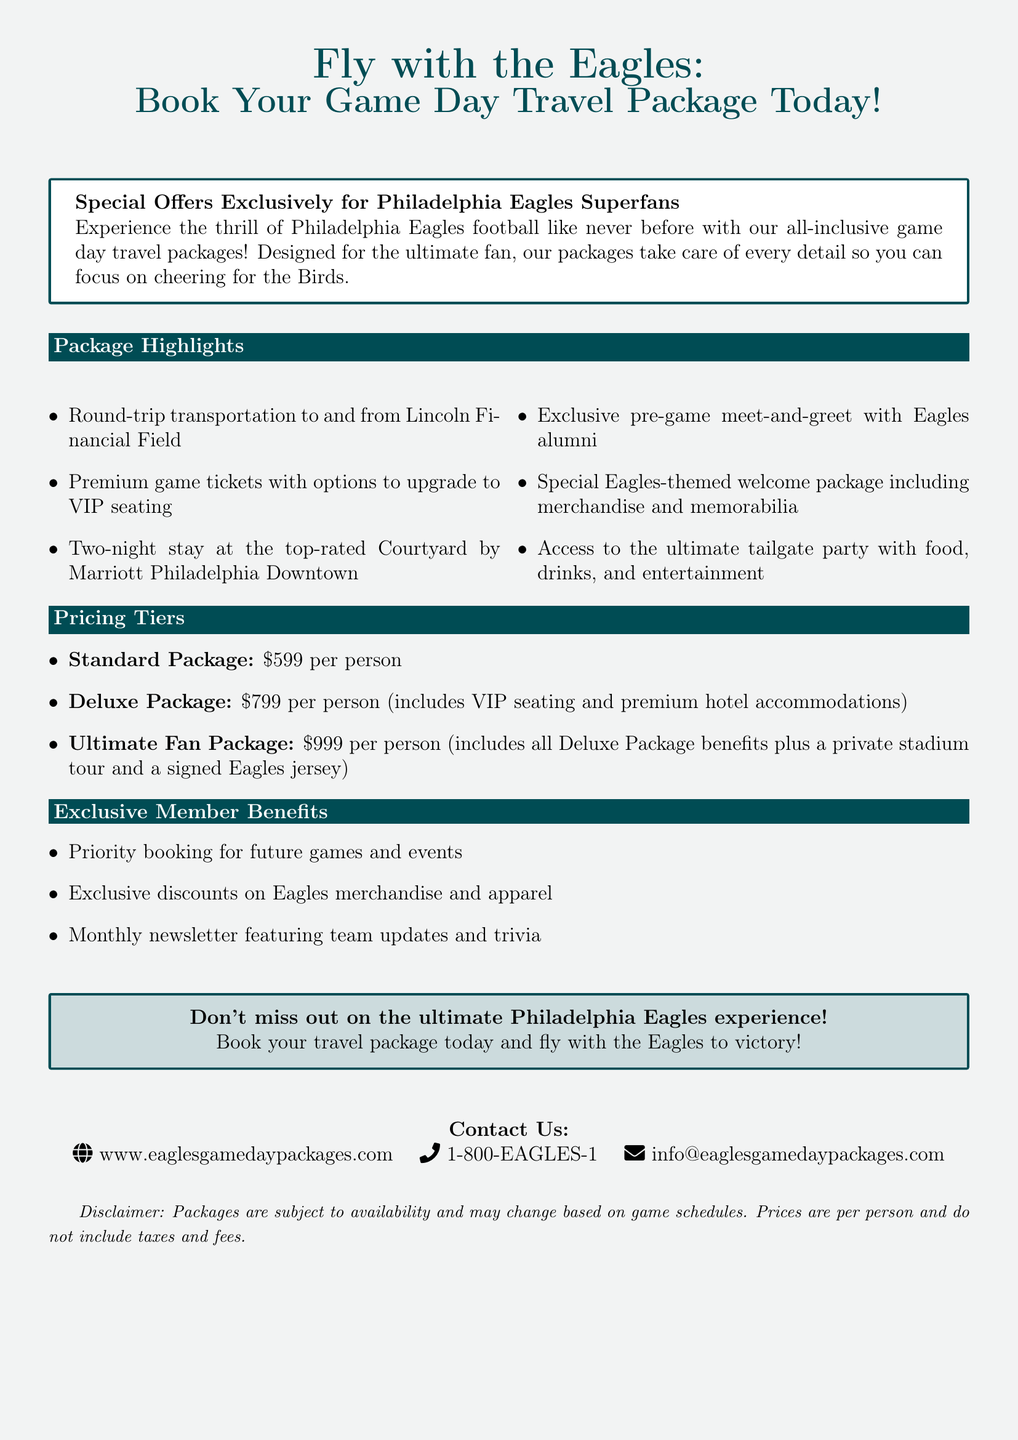What is the cost of the Standard Package? The cost listed for the Standard Package in the advertisement is $599 per person.
Answer: $599 What does the Ultimate Fan Package include? The Ultimate Fan Package includes all Deluxe Package benefits plus a private stadium tour and a signed Eagles jersey.
Answer: Private stadium tour and signed Eagles jersey What kind of transportation is provided? The document states that round-trip transportation to and from Lincoln Financial Field is included in the travel packages.
Answer: Round-trip transportation What benefit do exclusive members receive regarding merchandise? Exclusive members are provided exclusive discounts on Eagles merchandise and apparel as part of the benefits.
Answer: Exclusive discounts How many nights does the travel package hotel stay cover? The package includes a two-night stay at the top-rated hotel as stated in the advertisement.
Answer: Two nights What special event is included in the package? The advertisement mentions an exclusive pre-game meet-and-greet with Eagles alumni as one of the highlights.
Answer: Pre-game meet-and-greet with Eagles alumni What is the website to book the travel package? The contact information lists the website as www.eaglesgamedaypackages.com for booking the travel packages.
Answer: www.eaglesgamedaypackages.com How often will members receive updates from the newsletter? The exclusive member benefits include a monthly newsletter featuring team updates and trivia.
Answer: Monthly What color is used for the headline in the advertisement? The headline is in eagles green, which is RGB color code (0,76,84).
Answer: Eagles green 